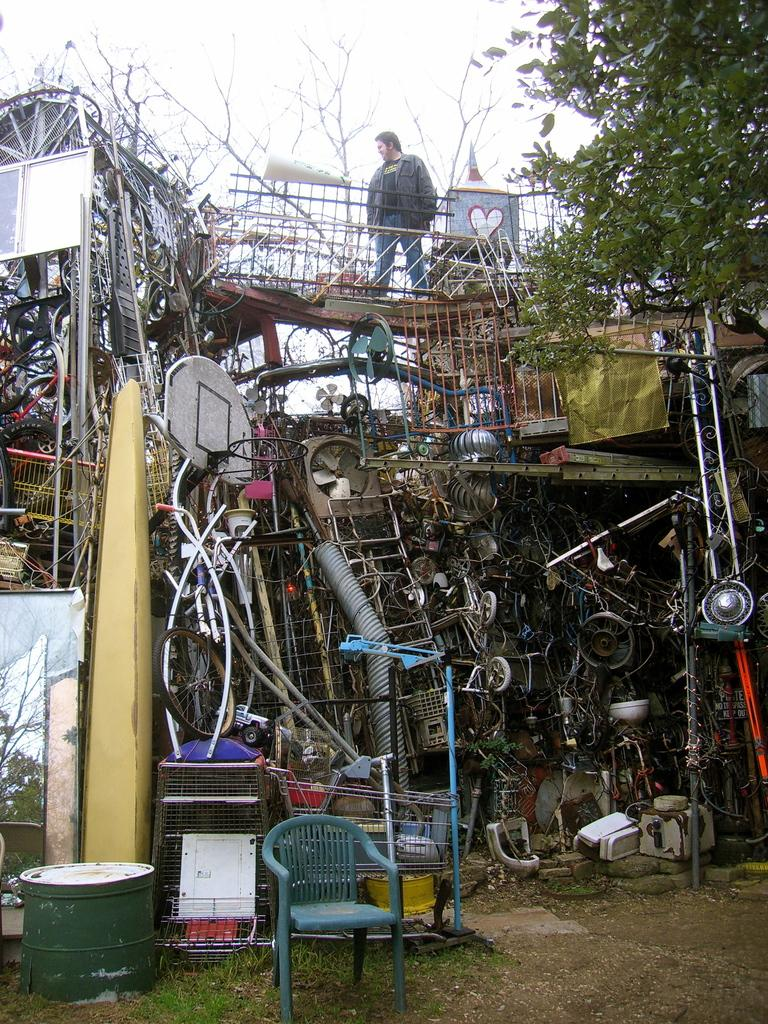What type of furniture is present in the image? There is a chair in the image. What material is the scrap in the image made of? The scrap in the image is made of metal. Can you describe the person in the image? There is a person standing in the image. What type of plant is visible in the image? There is a tree in the image. What is visible at the top of the image? The sky is visible at the top of the image. What type of meal is being prepared on the chair in the image? There is no meal being prepared in the image, and the chair is not being used for cooking purposes. What type of brass object can be seen in the image? There is no brass object present in the image. 